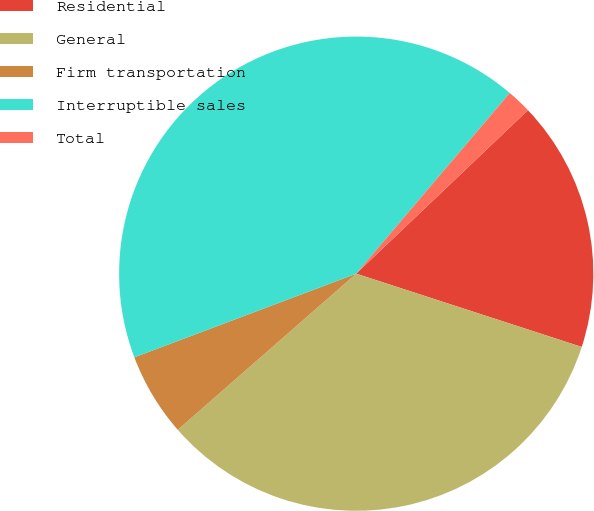Convert chart to OTSL. <chart><loc_0><loc_0><loc_500><loc_500><pie_chart><fcel>Residential<fcel>General<fcel>Firm transportation<fcel>Interruptible sales<fcel>Total<nl><fcel>17.11%<fcel>33.56%<fcel>5.7%<fcel>41.95%<fcel>1.68%<nl></chart> 